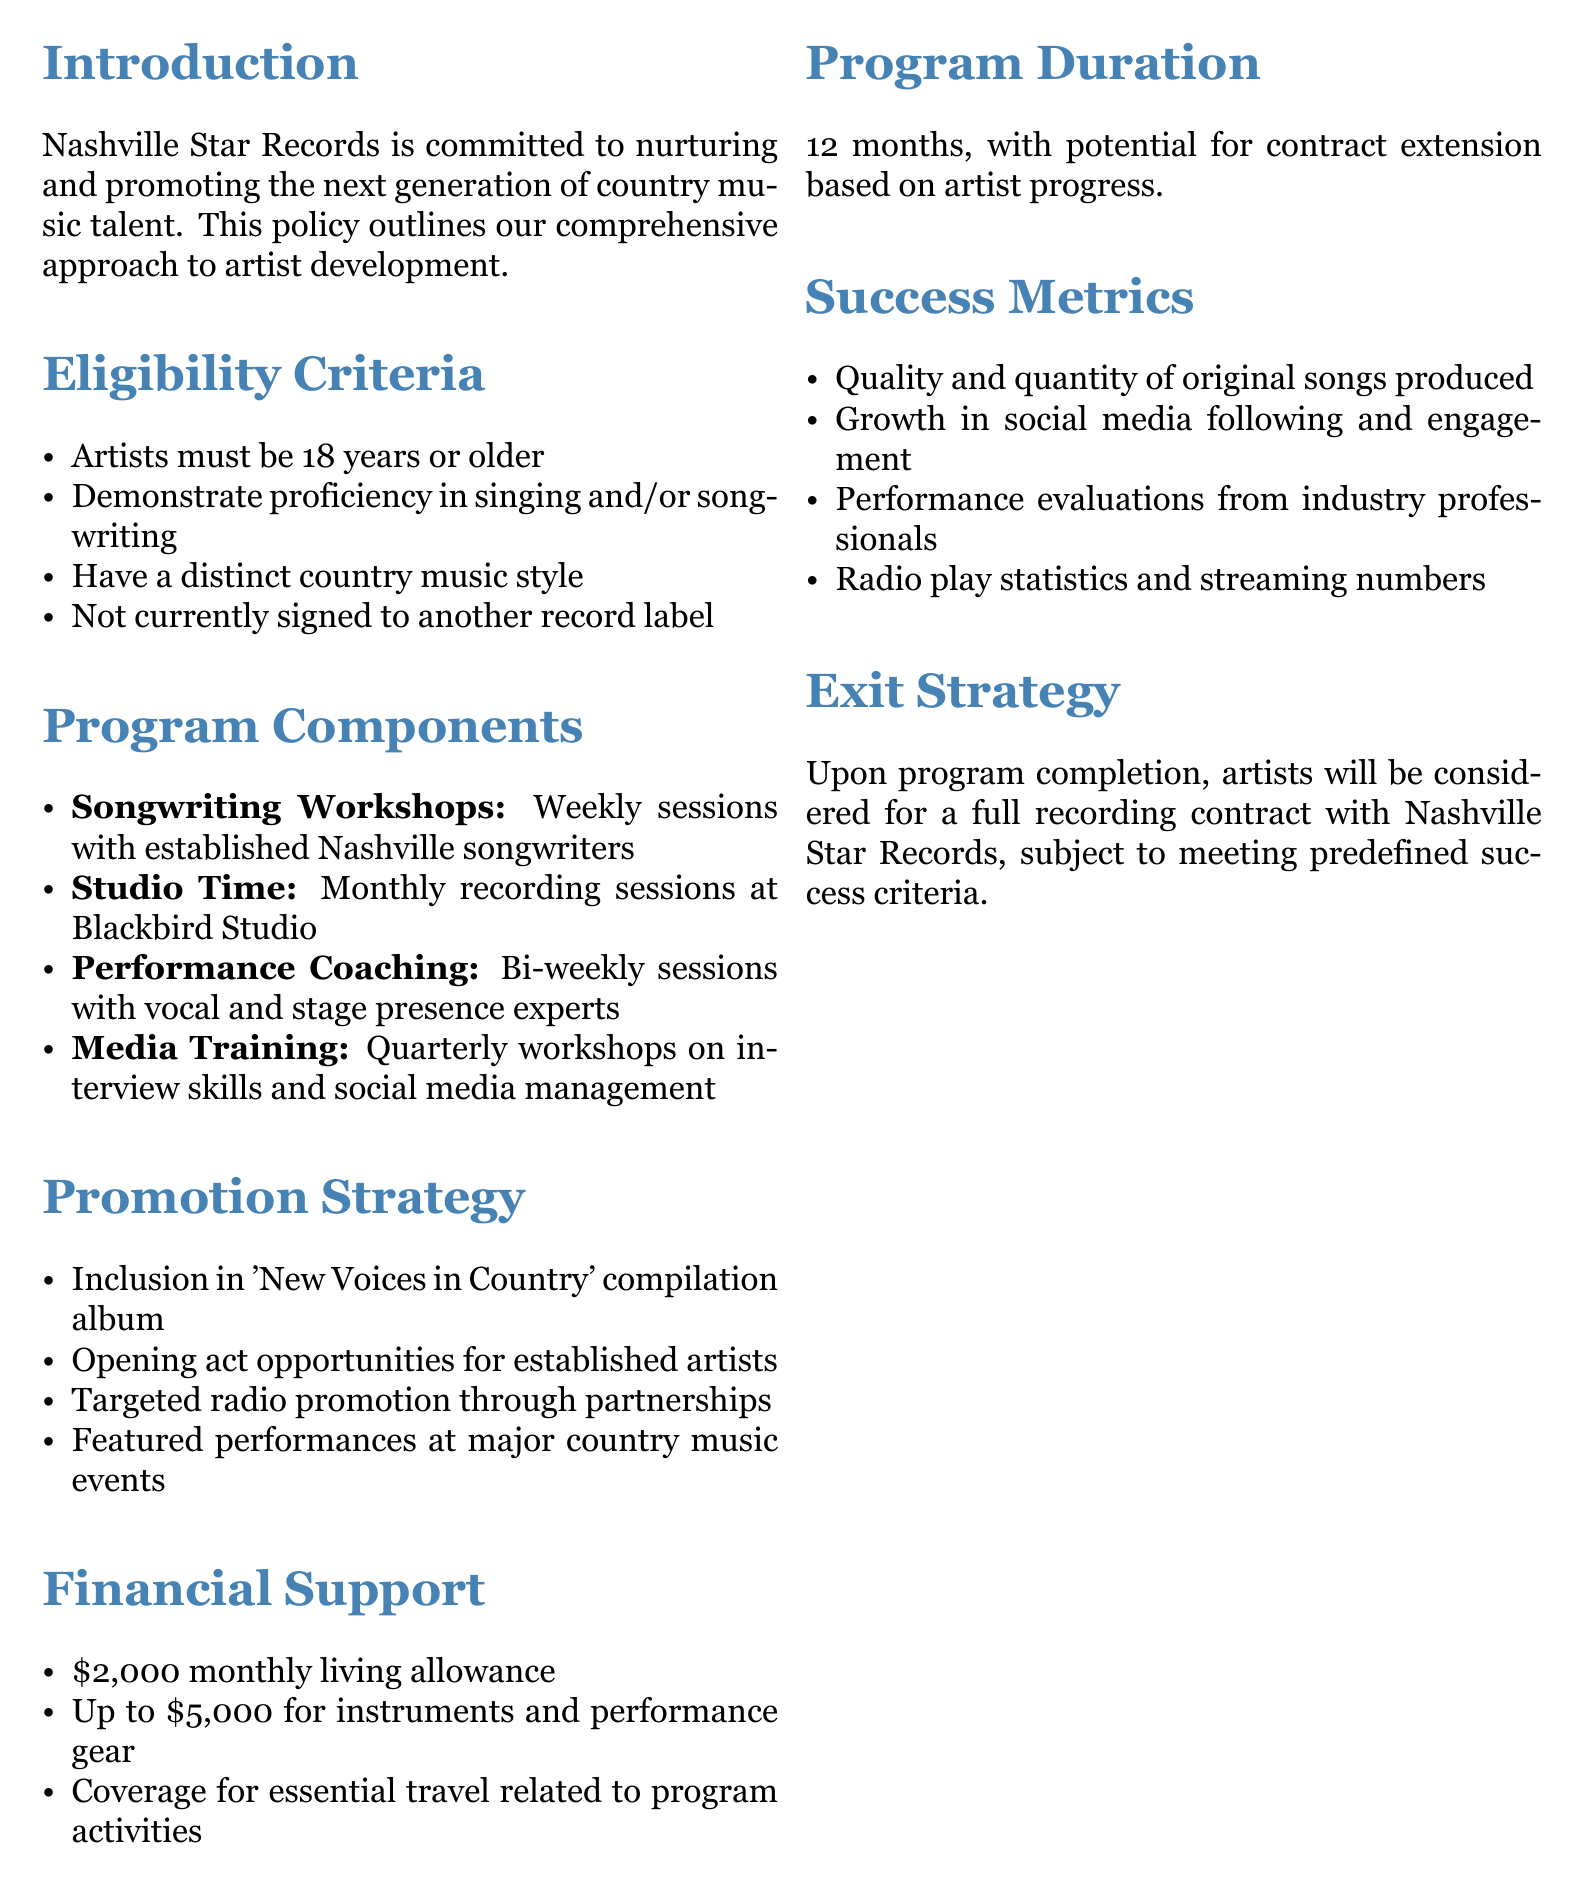What is the age requirement for artists? The policy states that artists must be 18 years or older to be eligible for the program.
Answer: 18 years What is included in the monthly support for artists? The document outlines that artists receive a $2,000 monthly living allowance.
Answer: $2,000 How long is the program duration? The document mentions that the program lasts for 12 months.
Answer: 12 months What is a key component of the promotion strategy? The policy highlights that a compilation album titled 'New Voices in Country' will feature participating artists.
Answer: 'New Voices in Country' What type of training do artists receive for performance? The document specifies that artists will have bi-weekly sessions with experts focused on vocal and stage presence.
Answer: Performance Coaching What is a criterion for success measurement? It mentions that growth in social media following and engagement is one of the success metrics.
Answer: Social media growth What financial support is available for instruments? The artists have access to up to $5,000 for instruments and performance gear as per the policy.
Answer: Up to $5,000 What happens upon program completion? The document states that artists will be considered for a full recording contract, contingent on meeting success criteria.
Answer: Full recording contract What type of workshops are conducted for songwriting? The policy describes weekly sessions with established Nashville songwriters as part of the program's components.
Answer: Songwriting Workshops 